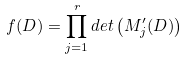Convert formula to latex. <formula><loc_0><loc_0><loc_500><loc_500>f ( D ) = \prod _ { j = 1 } ^ { r } d e t \left ( M _ { j } ^ { \prime } ( D ) \right )</formula> 